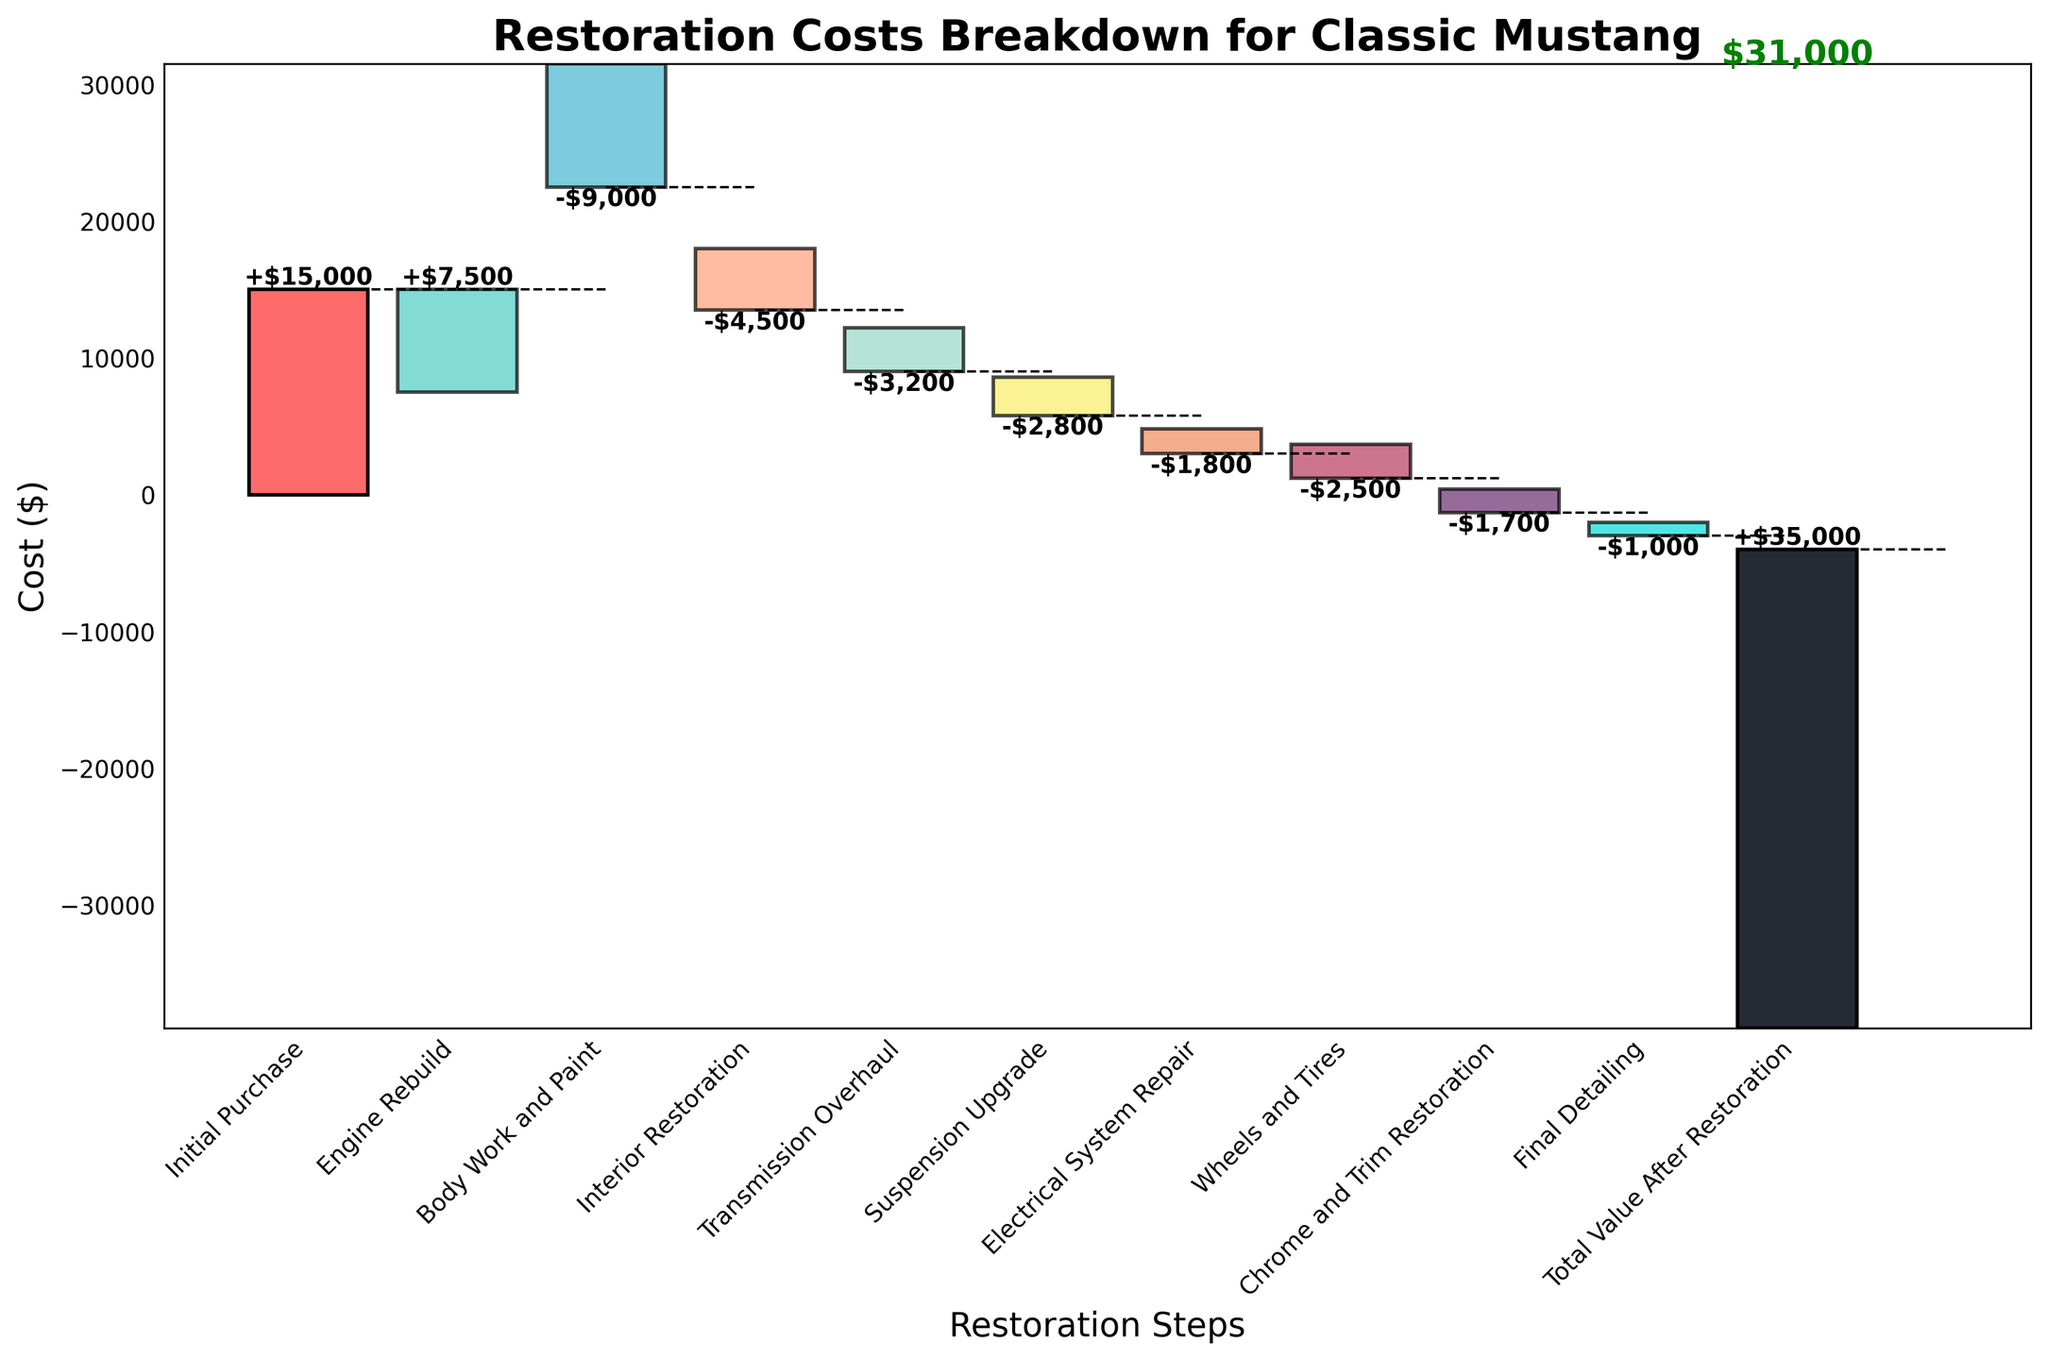What is the title of the chart? The title is provided at the top of the chart.
Answer: Restoration Costs Breakdown for Classic Mustang How many categories of costs are displayed in the chart? The bars and x-axis labels together represent the number of categories.
Answer: 10 What color represents the 'Interior Restoration' cost? Each bar has a distinct color and the x-axis label can help identify it.
Answer: #F9ED69 Which restoration step has the highest cost? The highest bar in terms of absolute value represents the highest cost.
Answer: Initial Purchase Calculate the total amount spent on the 'Transmission Overhaul' and 'Suspension Upgrade'. Add the values for 'Transmission Overhaul' and 'Suspension Upgrade', both of which can be read from their respective bars.
Answer: -$6,000 Is the cost of 'Body Work and Paint' bigger than the cost of 'Engine Rebuild'? Compare the absolute values of 'Body Work and Paint' and 'Engine Rebuild' from the figure.
Answer: Yes Which step incurs the least cost? Identify the smallest absolute value among the bars except 'Initial Purchase' and 'Total Value After Restoration'.
Answer: Final Detailing What is the total cost before the final detailing? Add all individual step costs except 'Final Detailing' and 'Total Value After Restoration'. Sum the values: $15,000 + $7,500 - $9,000 - $4,500 - $3,200 - $2,800 - $1,800 - $2,500 - $1,700 = -$2,000
Answer: -$2,000 How does the suspension upgrade cost compare to the electrical system repair cost? Compare the values from the 'Suspension Upgrade' and 'Electrical System Repair' bars.
Answer: Suspension upgrade is higher What's the cumulative cost after the 'Chrome and Trim Restoration'? Sum up all values from the initial step to 'Chrome and Trim Restoration': $15,000 + $7,500 - $9,000 - $4,500 - $3,200 - $2,800 - $1,800 - $2,500 - $1,700 = -$3,000
Answer: -$3,000 